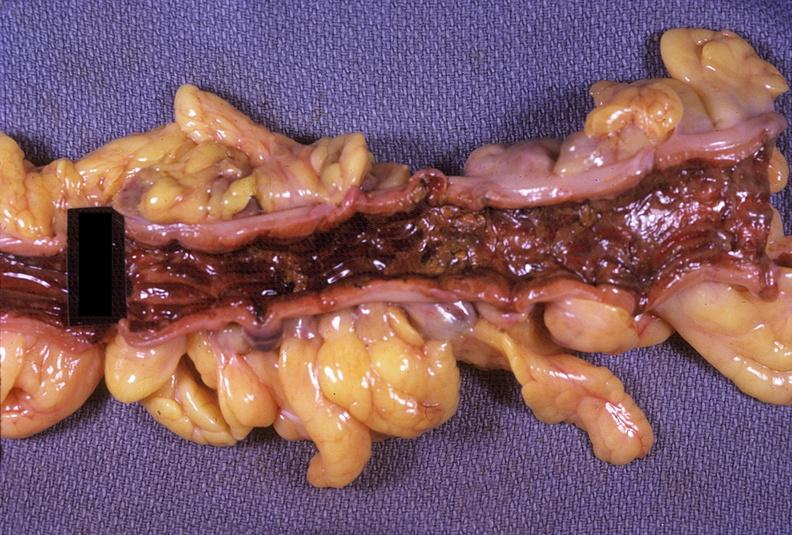what is present?
Answer the question using a single word or phrase. Gastrointestinal 